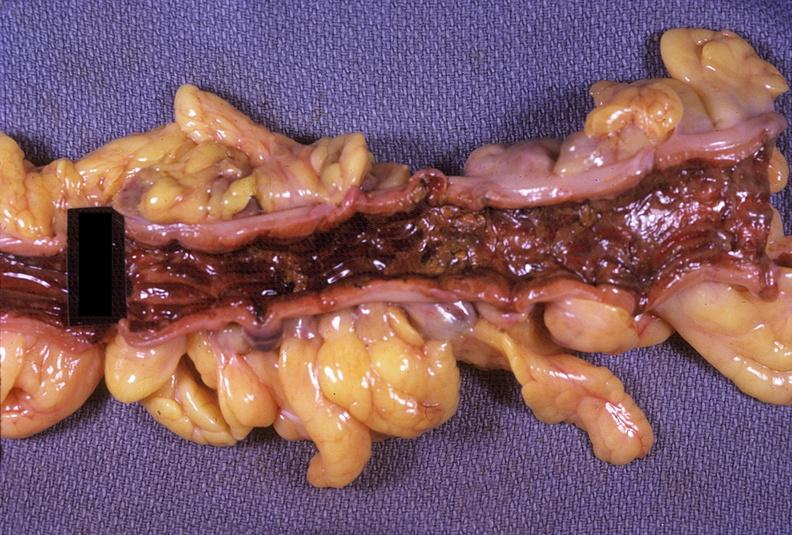what is present?
Answer the question using a single word or phrase. Gastrointestinal 